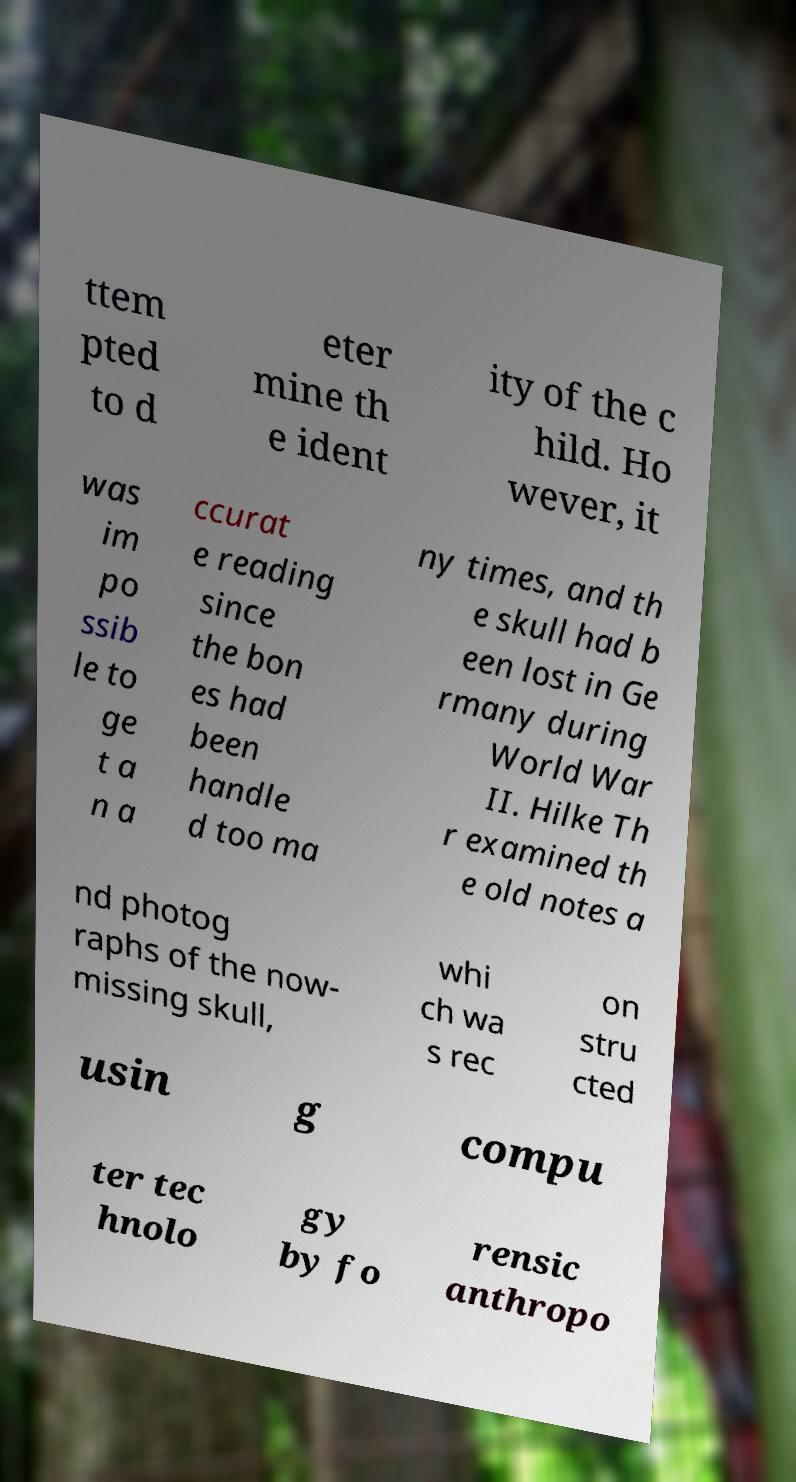I need the written content from this picture converted into text. Can you do that? ttem pted to d eter mine th e ident ity of the c hild. Ho wever, it was im po ssib le to ge t a n a ccurat e reading since the bon es had been handle d too ma ny times, and th e skull had b een lost in Ge rmany during World War II. Hilke Th r examined th e old notes a nd photog raphs of the now- missing skull, whi ch wa s rec on stru cted usin g compu ter tec hnolo gy by fo rensic anthropo 